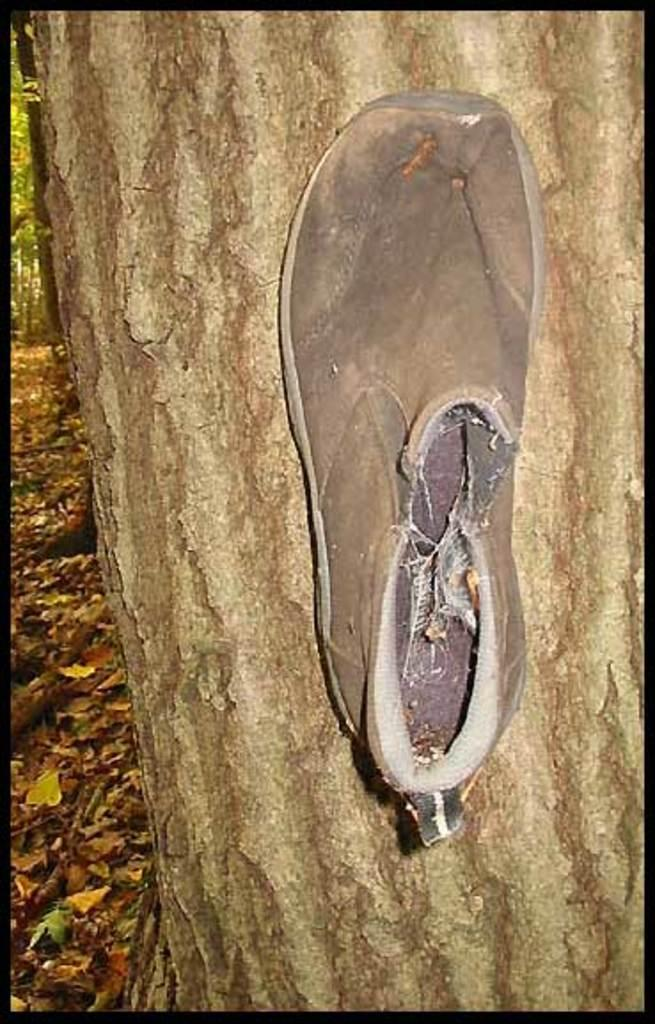What is placed on the tree stem in the image? There is a grey color shoe placed on a tree stem. What type of vegetation can be seen in the image? Dried leaves and twigs are visible in the image. What type of card is being used as fuel in the image? There is no card or fuel present in the image. 